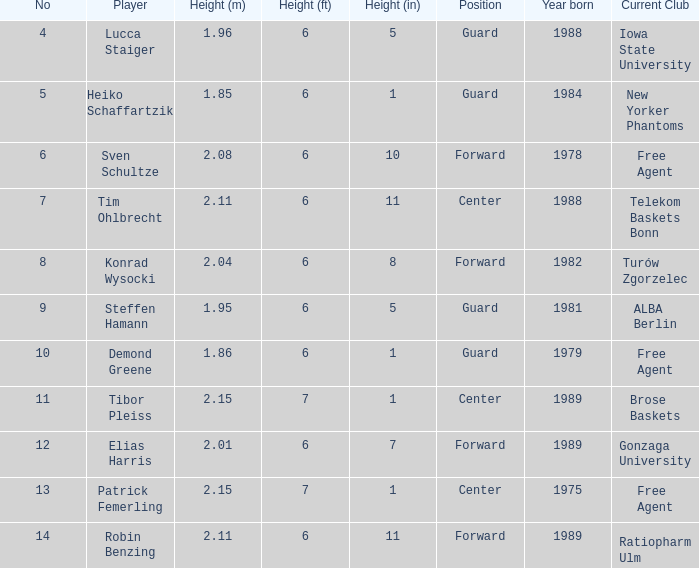Name the height for the player born 1989 and height 2.11 6' 11". 